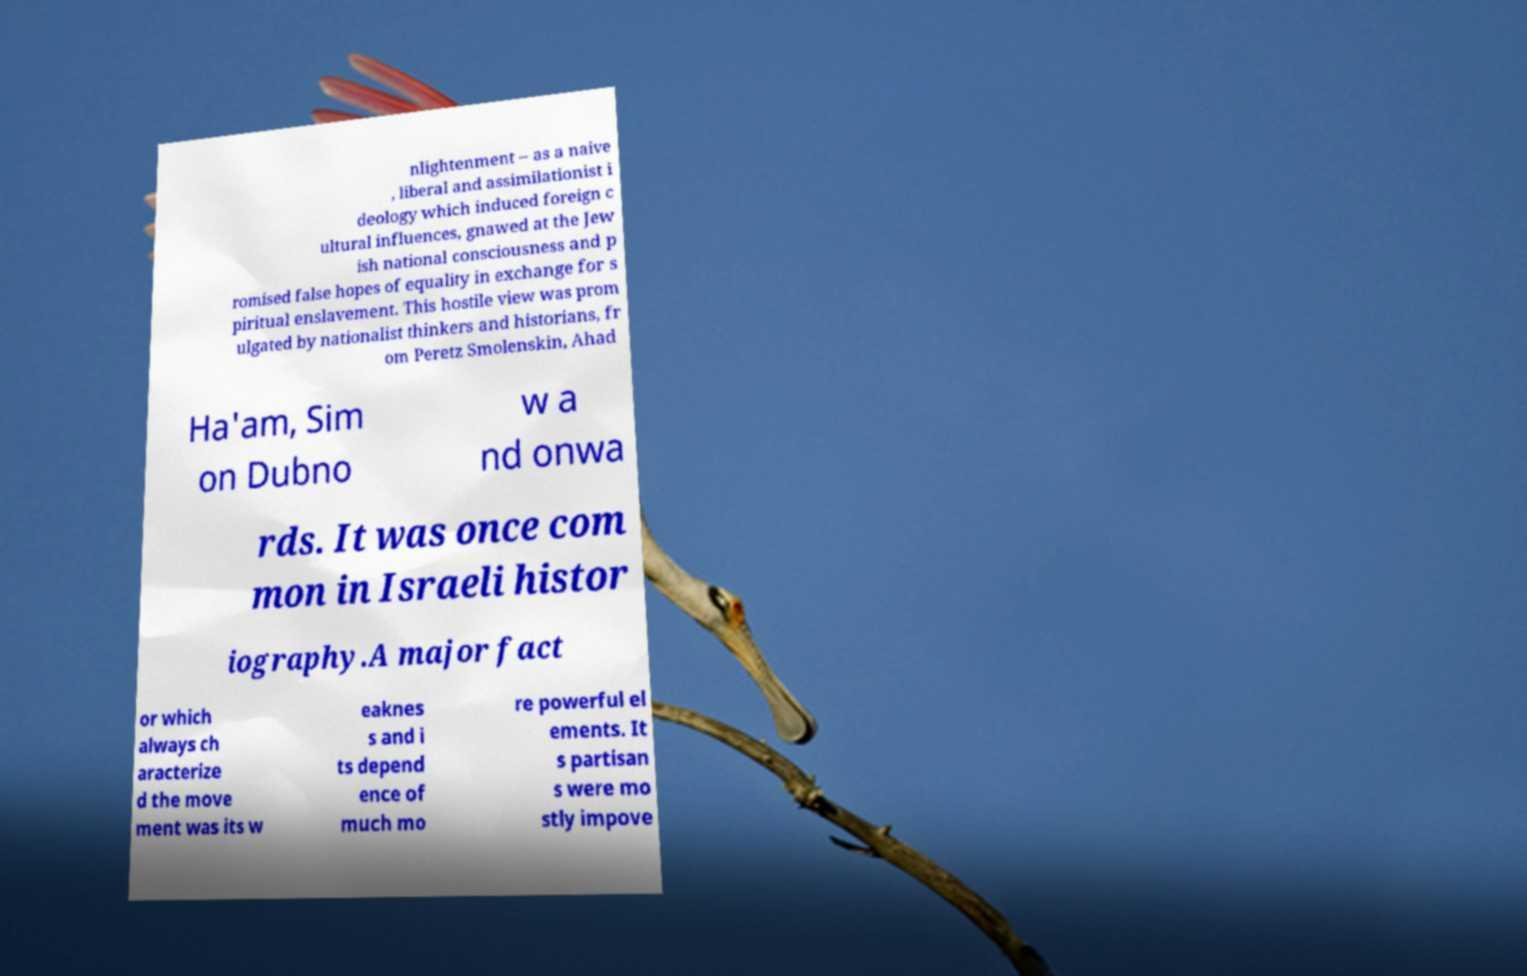For documentation purposes, I need the text within this image transcribed. Could you provide that? nlightenment – as a naive , liberal and assimilationist i deology which induced foreign c ultural influences, gnawed at the Jew ish national consciousness and p romised false hopes of equality in exchange for s piritual enslavement. This hostile view was prom ulgated by nationalist thinkers and historians, fr om Peretz Smolenskin, Ahad Ha'am, Sim on Dubno w a nd onwa rds. It was once com mon in Israeli histor iography.A major fact or which always ch aracterize d the move ment was its w eaknes s and i ts depend ence of much mo re powerful el ements. It s partisan s were mo stly impove 